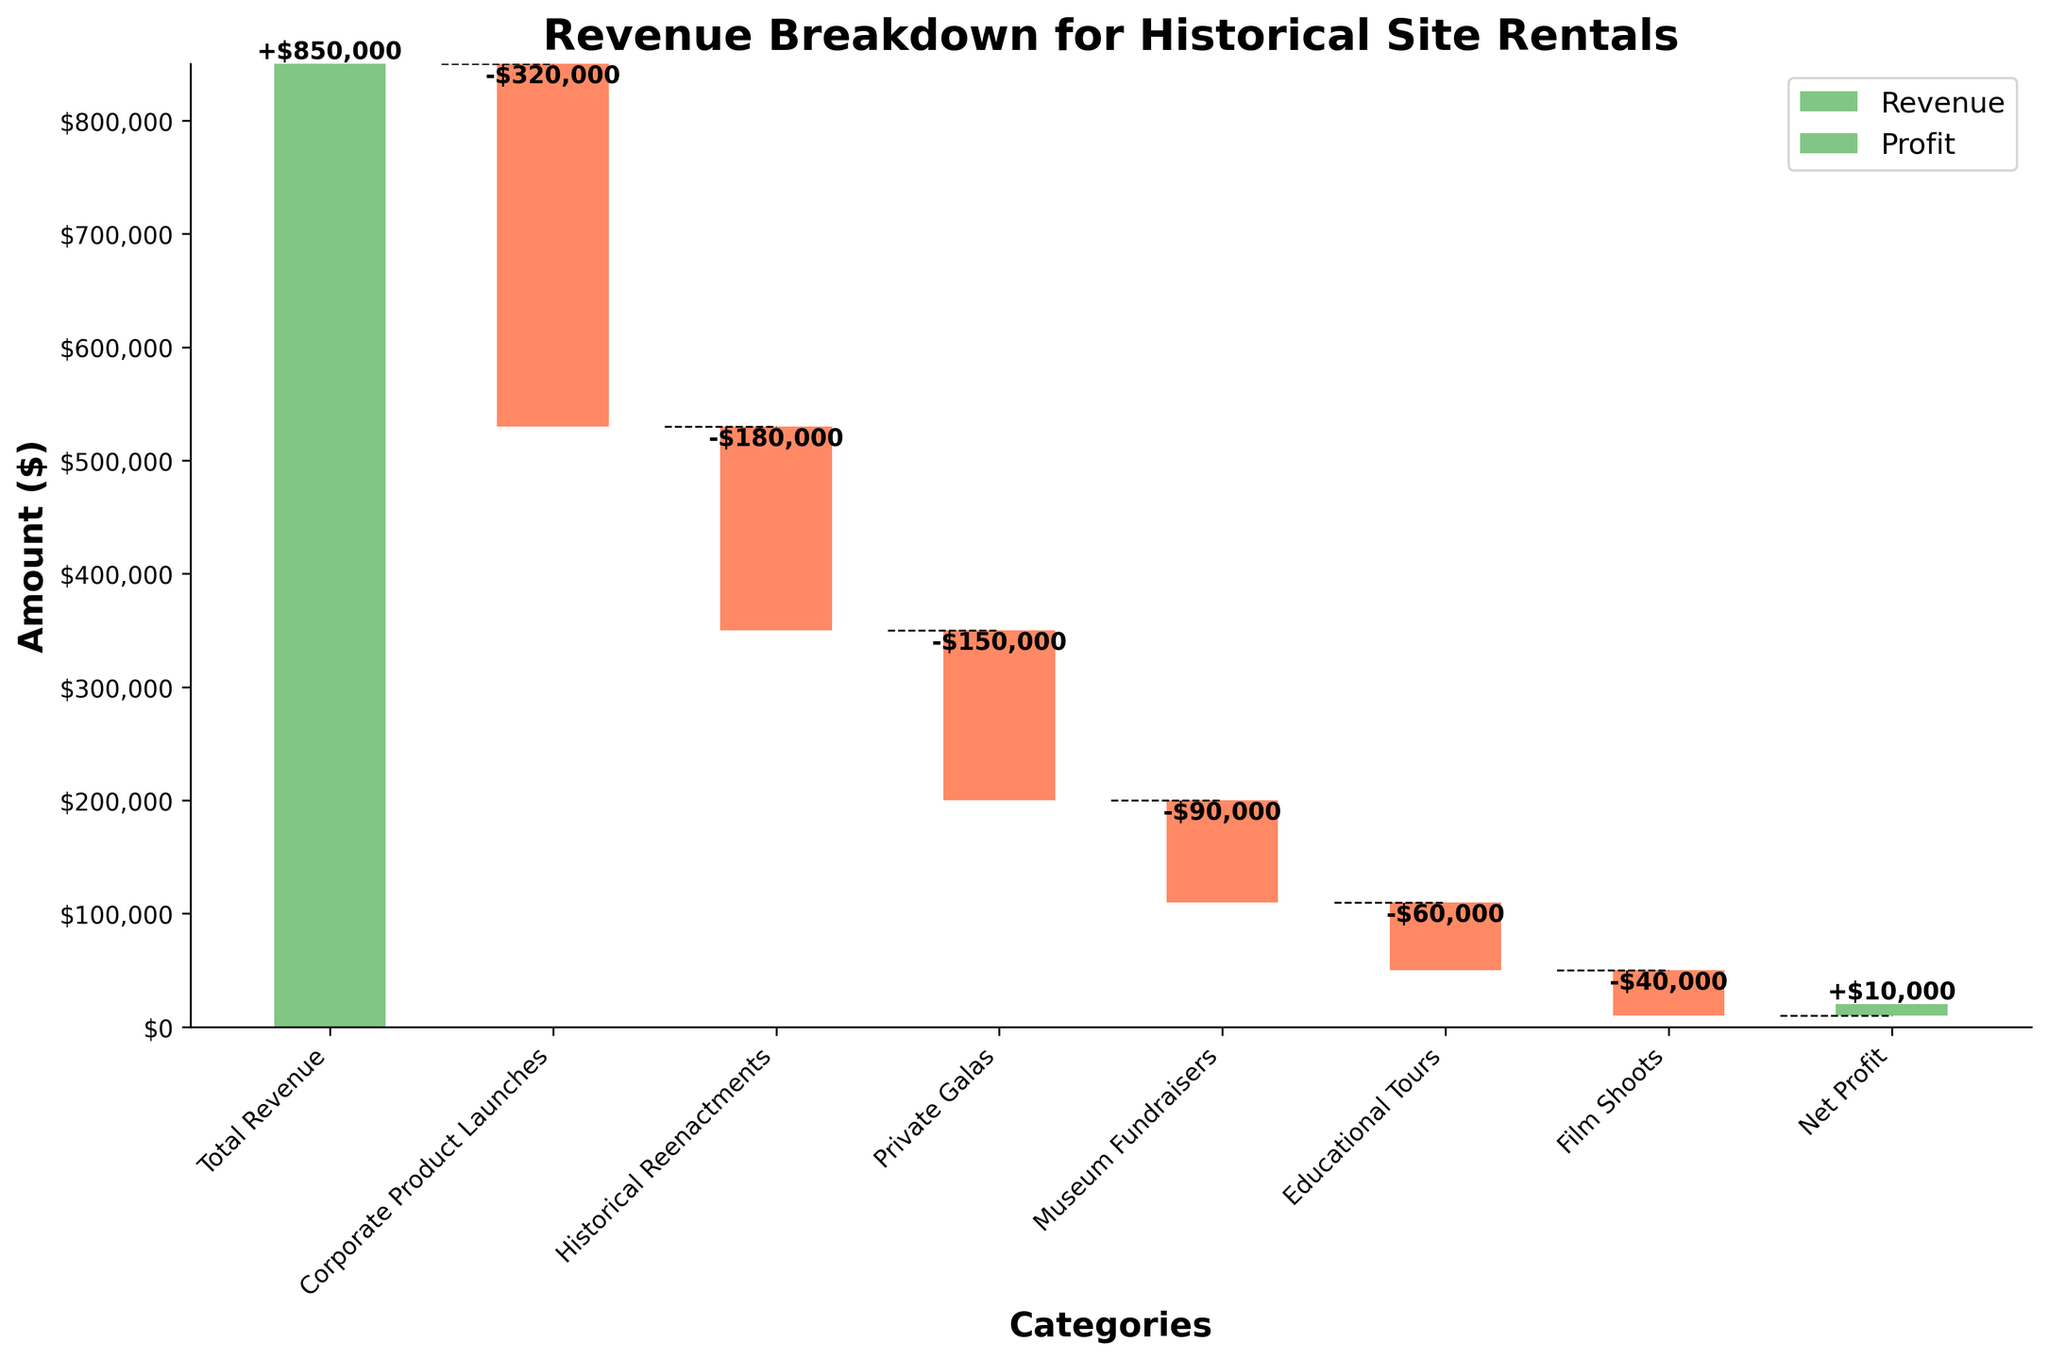What's the total revenue for historical site rentals? The total revenue is mentioned at the beginning of the chart and is represented by the first bar in green color.
Answer: $850,000 How much revenue is generated from historical reenactments? The revenue from historical reenactments is represented by the second bar labeled "Historical Reenactments," which is colored red. The value associated with this bar is -$180,000.
Answer: -$180,000 What is the net profit from all the event types combined? The net profit is shown at the end of the chart and is represented by the last bar in green color. The value associated with this bar is $10,000.
Answer: $10,000 Which event type leads to the largest revenue loss? To find the largest revenue loss, look for the bar with the largest negative value. The "Corporate Product Launches" bar has the largest negative value of -$320,000.
Answer: Corporate Product Launches What is the cumulative revenue after adding private galas to the total revenue? Starting with the total revenue of $850,000, subtract the revenue losses from "Corporate Product Launches" and "Historical Reenactments" before subtracting "Private Galas."
$850,000 - $320,000 = $530,000
$530,000 - $180,000 = $350,000
$350,000 - $150,000 = $200,000
Answer: $200,000 Which event type results in the smallest loss, and how much is it? Look for the bar with the smallest negative value. The "Film Shoots" bar has the smallest negative value of -$40,000.
Answer: Film Shoots, -$40,000 By how much does the cumulative revenue decrease after museum fundraisers? Determine the revenue loss by looking at the "Museum Fundraisers" bar, which is -$90,000. The cumulative revenue prior to this can be calculated as:
$200,000 (after Private Galas) - $90,000 = $110,000
Answer: $90,000 decrease, leaving $110,000 What percentage of the total revenue is lost due to educational tours? First, find the absolute value of the loss for "Educational Tours" which is $60,000. Divide it by the total revenue of $850,000 and multiply by 100 to convert to percentage.
($60,000 / $850,000) * 100 ≈ 7.06%
Answer: ~7.06% 